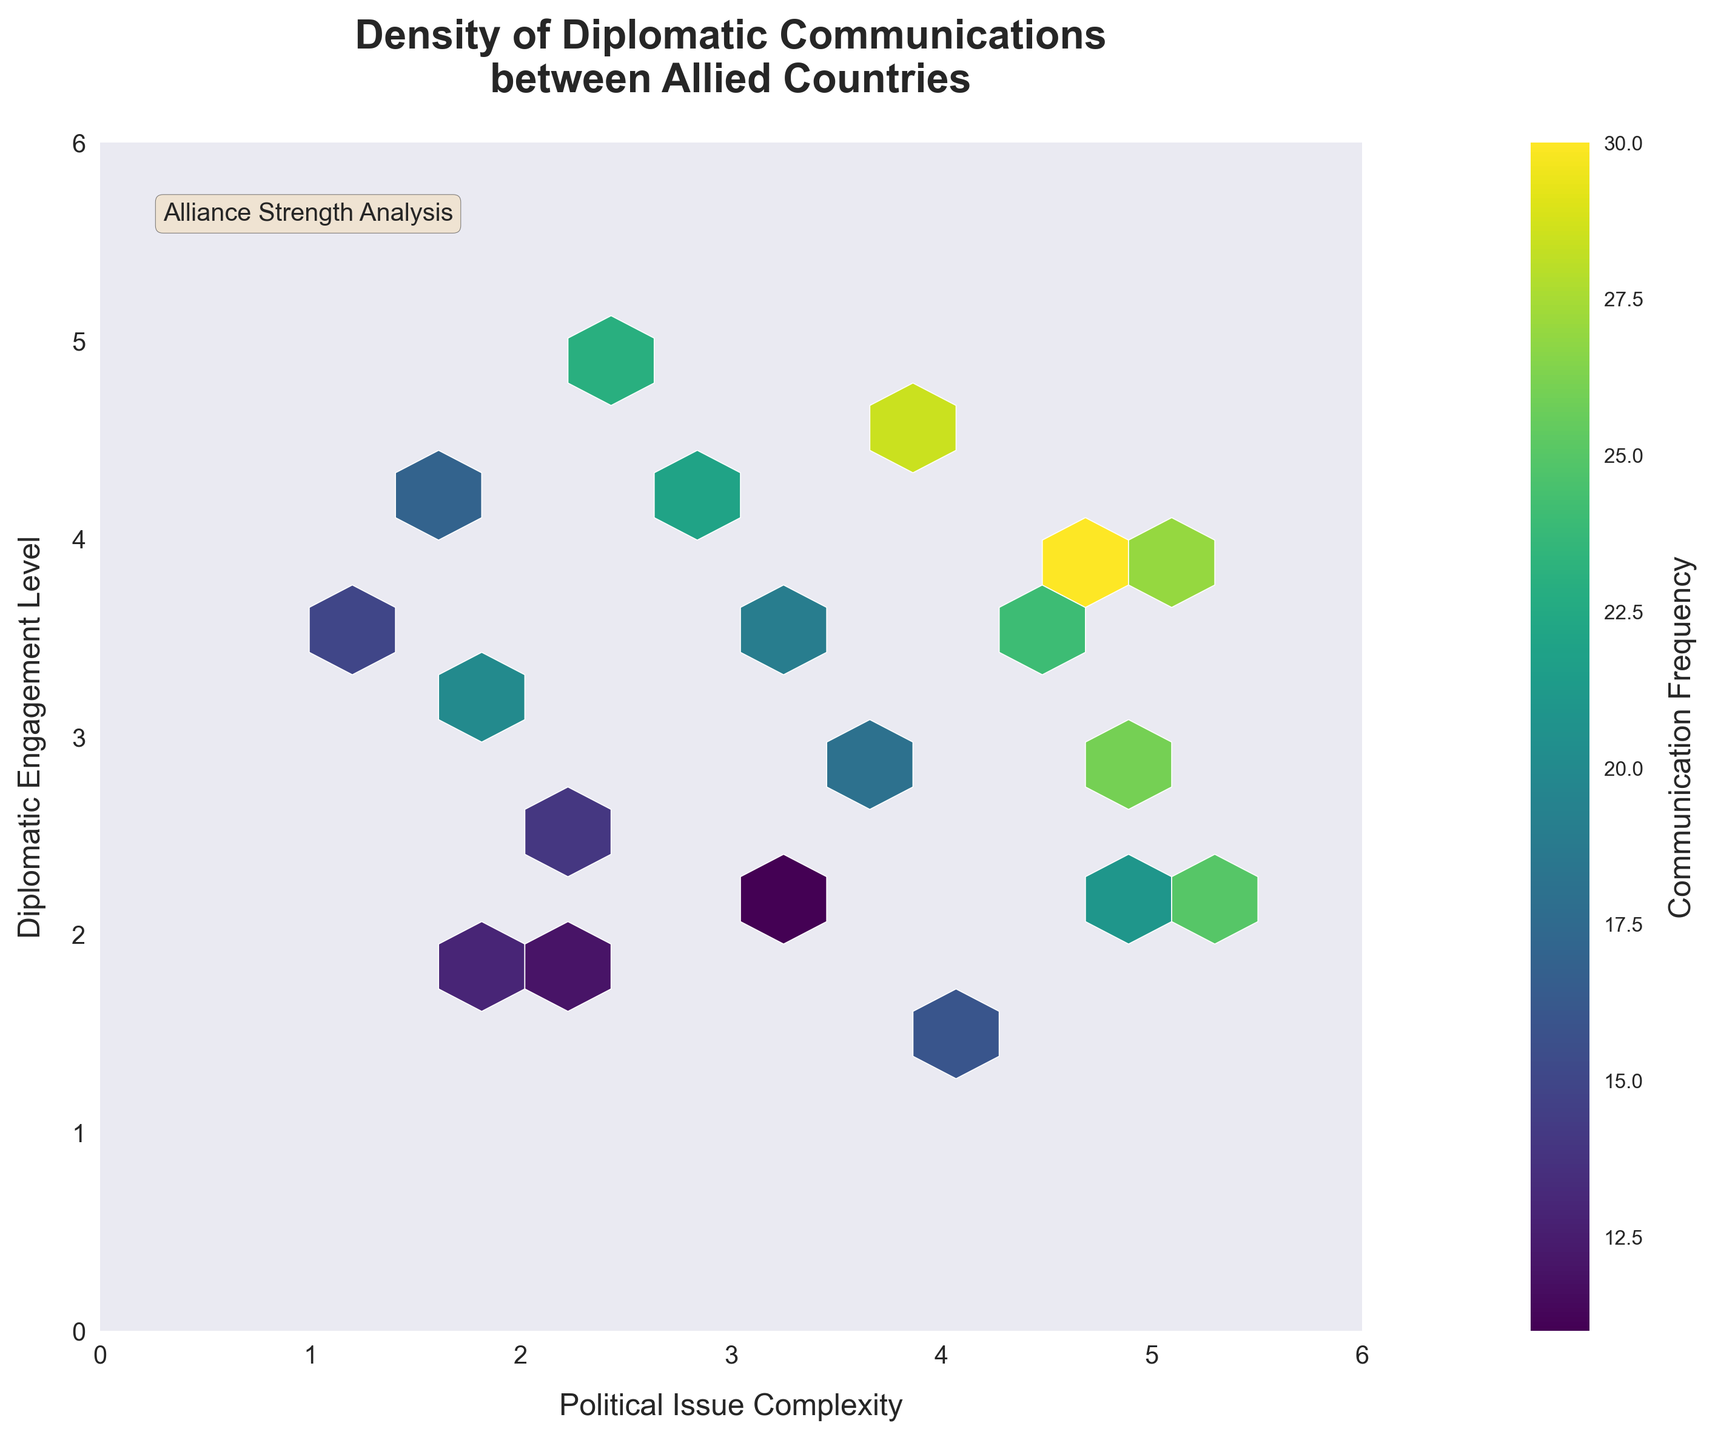What's the title of the figure? The title of the figure is written at the top in bold. It reads "Density of Diplomatic Communications between Allied Countries". This title helps identify the general subject and the scope of the data visualized.
Answer: Density of Diplomatic Communications between Allied Countries What are the X and Y axes labels? The X and Y axes labels are written along the respective axes. The X-axis is labeled "Political Issue Complexity" and the Y-axis is labeled "Diplomatic Engagement Level". These labels give context to what each axis represents.
Answer: Political Issue Complexity (X), Diplomatic Engagement Level (Y) What does the color represent in the hexbin plot? The color in the hexbin plot represents the frequency of diplomatic communications. This information is provided by the color bar on the right side of the plot, which also has a label "Communication Frequency". Darker colors correspond to higher frequencies.
Answer: Frequency of diplomatic communications What is the highest frequency represented in the plot? To find the highest frequency, we look at the color bar and identify the darkest color hexagons in the plot. These high-frequency hexagons correspond to the color bar's highest value.
Answer: 30 Which area of the plot shows the highest level of diplomatic engagement on issues with moderate-to-high complexity? Focus on the y-axis range that represents high diplomatic engagement levels, roughly between 2.5 and 4.5. Then, find the hexagons within this range with higher x-axis values indicating moderate-to-high complexity (values around 3-5). Evaluate the color brightness in this region for highest engagement. The densest region in this area is around (3.5, 3.8).
Answer: Around (3.5, 3.8) How does the frequency of communication change as the political issue complexity increases from 1 to 3? We need to observe the hexagons along the x-axis from values 1 to 3. Identify the color intensity along this range to understand if the frequency gets higher or lower. We can see that there is an increase in the density of darker hexagons, especially around 1.8 to 3.0.
Answer: Generally increases Is there a notable relationship between high diplomatic engagement and issue complexity? To determine this, we examine how the y-axis values (diplomatic engagement) change with increasing x-axis values (issue complexity). There are several high-frequency hexagons in regions where both coordinates are moderate to high (around 3.0 to 4.5), suggesting a positive relationship.
Answer: Yes, positive Where is the area of least diplomatic engagement and frequency in the plot? Identify the lightest-colored hexagons that are least frequent and at the lowest y-axis values. The bottom left corner, around coordinates close to (1.0, 1.5), shows lower engagement.
Answer: Around (1.0, 1.5) How is the distribution of the data related to the political issue complexity of 4 across different diplomatic engagement levels? Look at the vertical line where x equals 4 and determine the distribution of color intensity along this line. Higher concentrations of darker colors suggest distributed frequencies across different engagement levels. Notably, coordinates near (4, 3.8) and (4, 4.0) have the higher intensity.
Answer: Distributed, higher around (4, 3.8) 